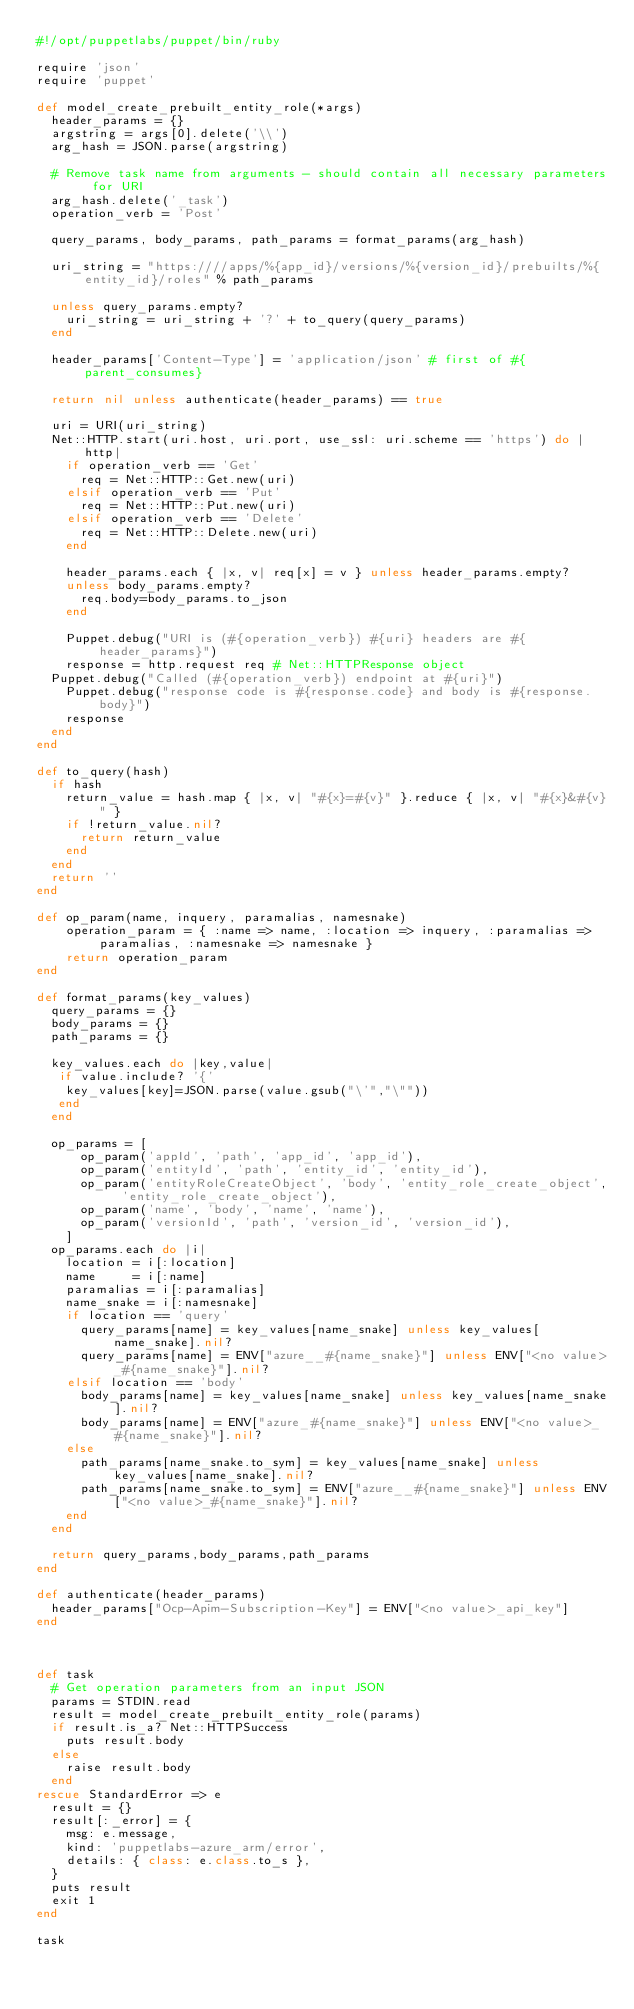<code> <loc_0><loc_0><loc_500><loc_500><_Ruby_>#!/opt/puppetlabs/puppet/bin/ruby

require 'json'
require 'puppet'

def model_create_prebuilt_entity_role(*args)
  header_params = {}
  argstring = args[0].delete('\\')
  arg_hash = JSON.parse(argstring)

  # Remove task name from arguments - should contain all necessary parameters for URI
  arg_hash.delete('_task')
  operation_verb = 'Post'

  query_params, body_params, path_params = format_params(arg_hash)

  uri_string = "https:////apps/%{app_id}/versions/%{version_id}/prebuilts/%{entity_id}/roles" % path_params

  unless query_params.empty?
    uri_string = uri_string + '?' + to_query(query_params)
  end

  header_params['Content-Type'] = 'application/json' # first of #{parent_consumes}

  return nil unless authenticate(header_params) == true

  uri = URI(uri_string)
  Net::HTTP.start(uri.host, uri.port, use_ssl: uri.scheme == 'https') do |http|
    if operation_verb == 'Get'
      req = Net::HTTP::Get.new(uri)
    elsif operation_verb == 'Put'
      req = Net::HTTP::Put.new(uri)
    elsif operation_verb == 'Delete'
      req = Net::HTTP::Delete.new(uri)
    end

    header_params.each { |x, v| req[x] = v } unless header_params.empty?
    unless body_params.empty?
      req.body=body_params.to_json
    end

    Puppet.debug("URI is (#{operation_verb}) #{uri} headers are #{header_params}")
    response = http.request req # Net::HTTPResponse object
	Puppet.debug("Called (#{operation_verb}) endpoint at #{uri}")
    Puppet.debug("response code is #{response.code} and body is #{response.body}")
    response
  end
end

def to_query(hash)
  if hash
    return_value = hash.map { |x, v| "#{x}=#{v}" }.reduce { |x, v| "#{x}&#{v}" }
    if !return_value.nil?
      return return_value
    end
  end
  return ''
end

def op_param(name, inquery, paramalias, namesnake)
    operation_param = { :name => name, :location => inquery, :paramalias => paramalias, :namesnake => namesnake }
    return operation_param
end

def format_params(key_values)
  query_params = {}
  body_params = {}
  path_params = {}

  key_values.each do |key,value|
   if value.include? '{'
    key_values[key]=JSON.parse(value.gsub("\'","\""))
   end
  end

  op_params = [
      op_param('appId', 'path', 'app_id', 'app_id'),
      op_param('entityId', 'path', 'entity_id', 'entity_id'),
      op_param('entityRoleCreateObject', 'body', 'entity_role_create_object', 'entity_role_create_object'),
      op_param('name', 'body', 'name', 'name'),
      op_param('versionId', 'path', 'version_id', 'version_id'),
    ]
  op_params.each do |i|
    location = i[:location]
    name     = i[:name]
    paramalias = i[:paramalias]
    name_snake = i[:namesnake]
    if location == 'query'
      query_params[name] = key_values[name_snake] unless key_values[name_snake].nil?
      query_params[name] = ENV["azure__#{name_snake}"] unless ENV["<no value>_#{name_snake}"].nil?
    elsif location == 'body'
      body_params[name] = key_values[name_snake] unless key_values[name_snake].nil?
      body_params[name] = ENV["azure_#{name_snake}"] unless ENV["<no value>_#{name_snake}"].nil?
    else
      path_params[name_snake.to_sym] = key_values[name_snake] unless key_values[name_snake].nil?
      path_params[name_snake.to_sym] = ENV["azure__#{name_snake}"] unless ENV["<no value>_#{name_snake}"].nil?
    end
  end
  
  return query_params,body_params,path_params
end

def authenticate(header_params)
  header_params["Ocp-Apim-Subscription-Key"] = ENV["<no value>_api_key"]
end



def task
  # Get operation parameters from an input JSON
  params = STDIN.read
  result = model_create_prebuilt_entity_role(params)
  if result.is_a? Net::HTTPSuccess
    puts result.body
  else
    raise result.body
  end
rescue StandardError => e
  result = {}
  result[:_error] = {
    msg: e.message,
    kind: 'puppetlabs-azure_arm/error',
    details: { class: e.class.to_s },
  }
  puts result
  exit 1
end

task</code> 